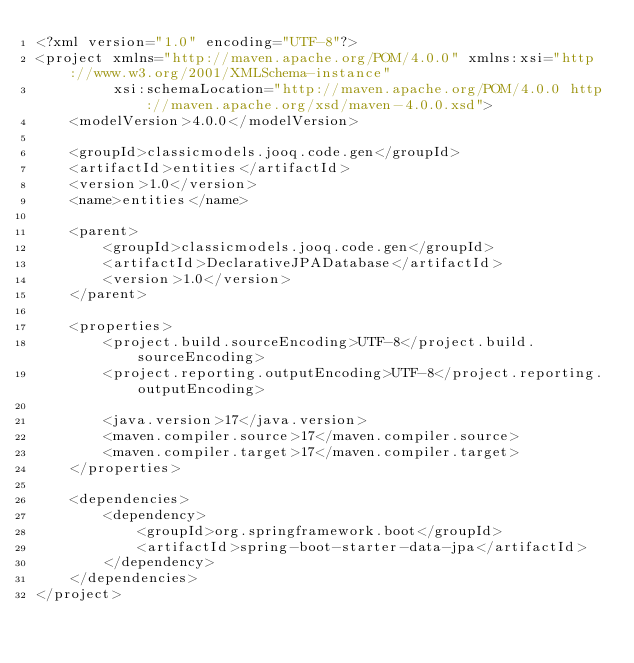Convert code to text. <code><loc_0><loc_0><loc_500><loc_500><_XML_><?xml version="1.0" encoding="UTF-8"?>
<project xmlns="http://maven.apache.org/POM/4.0.0" xmlns:xsi="http://www.w3.org/2001/XMLSchema-instance"
         xsi:schemaLocation="http://maven.apache.org/POM/4.0.0 http://maven.apache.org/xsd/maven-4.0.0.xsd">
    <modelVersion>4.0.0</modelVersion>

    <groupId>classicmodels.jooq.code.gen</groupId>
    <artifactId>entities</artifactId>
    <version>1.0</version>    
    <name>entities</name>    
    
    <parent>
        <groupId>classicmodels.jooq.code.gen</groupId>
        <artifactId>DeclarativeJPADatabase</artifactId>
        <version>1.0</version>
    </parent>    

    <properties>
        <project.build.sourceEncoding>UTF-8</project.build.sourceEncoding>
        <project.reporting.outputEncoding>UTF-8</project.reporting.outputEncoding>
        
        <java.version>17</java.version>                
        <maven.compiler.source>17</maven.compiler.source>
        <maven.compiler.target>17</maven.compiler.target>            
    </properties>
    
    <dependencies>                          
        <dependency>
            <groupId>org.springframework.boot</groupId>
            <artifactId>spring-boot-starter-data-jpa</artifactId>
        </dependency>                             
    </dependencies>   
</project>
</code> 